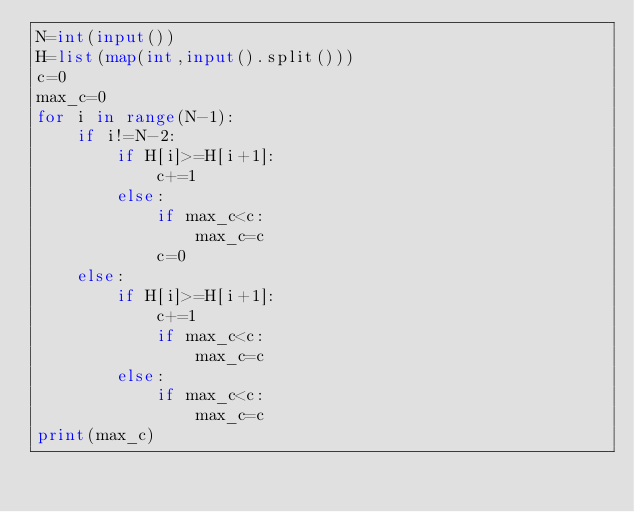<code> <loc_0><loc_0><loc_500><loc_500><_Python_>N=int(input())
H=list(map(int,input().split()))
c=0
max_c=0
for i in range(N-1):
    if i!=N-2:
        if H[i]>=H[i+1]:
            c+=1
        else:
            if max_c<c:
                max_c=c
            c=0
    else:
        if H[i]>=H[i+1]:
            c+=1
            if max_c<c:
                max_c=c
        else:
            if max_c<c:
                max_c=c
print(max_c)</code> 